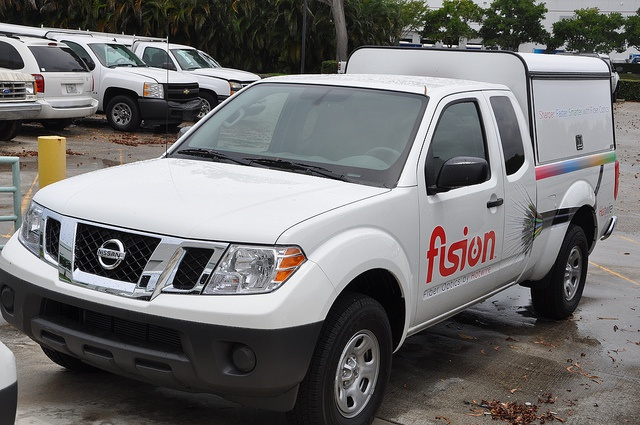Describe the objects in this image and their specific colors. I can see truck in black, lightgray, darkgray, and gray tones, car in black, lightgray, darkgray, and gray tones, car in black, darkgray, gray, and lightgray tones, car in black, lightgray, gray, and darkgray tones, and car in black, gray, lightgray, and darkgray tones in this image. 